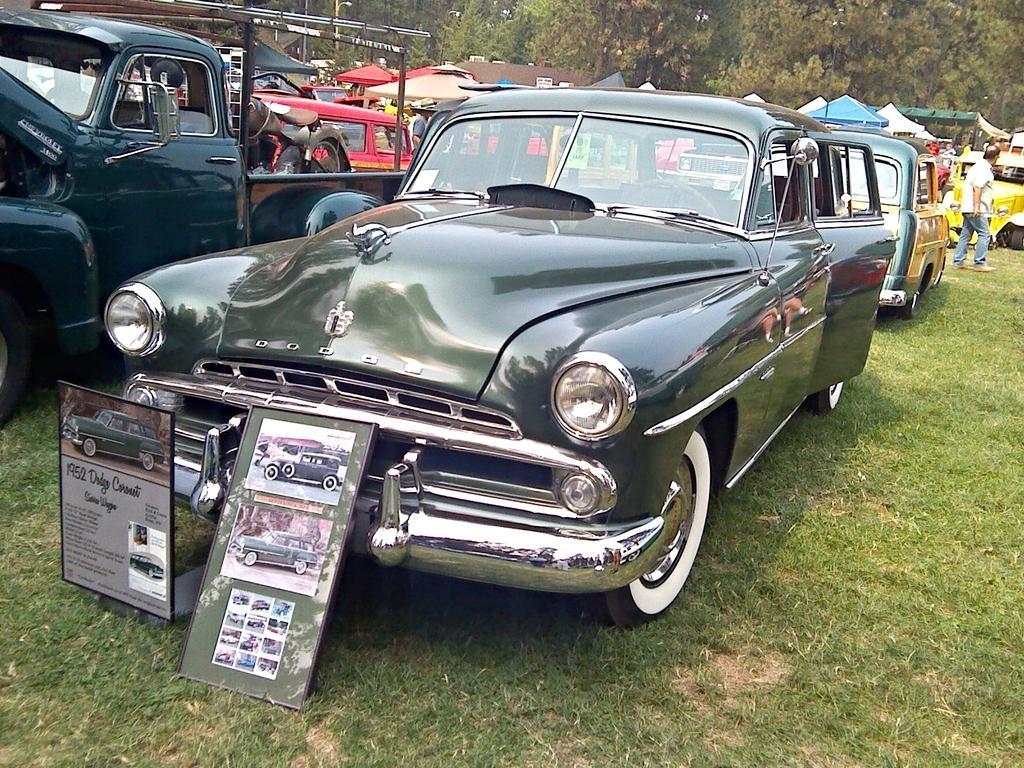Please provide a concise description of this image. In this image I can see the vehicles. I can see the grass. In the background, I can see the trees. 